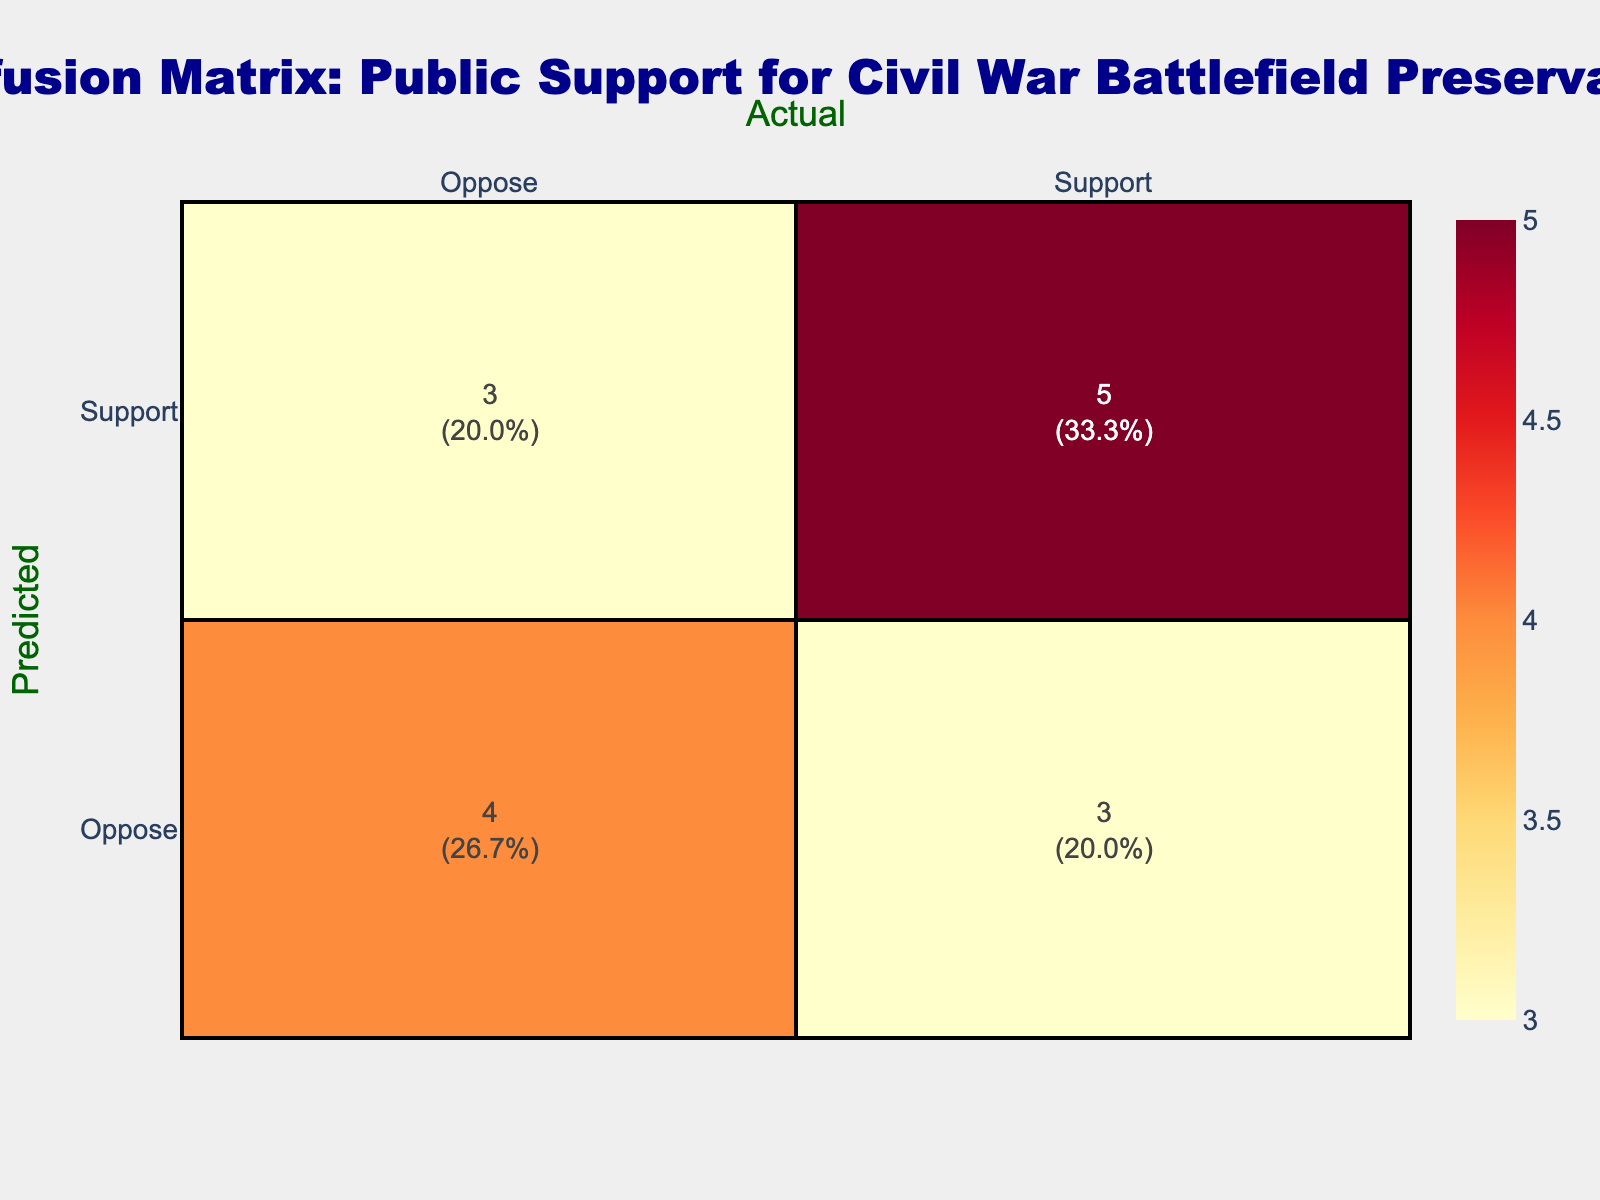What is the count of predicted support when the actual support is also support? In the table, we look for the intersection where both predicted and actual values are "Support." This occurs in three instances.
Answer: 3 What is the total count of instances where the prediction was "Oppose"? We sum the total counts in the "Oppose" row, which includes two instances of actual "Oppose" (count 2) and two instances of actual "Support" (count 2), giving a total of four.
Answer: 4 Is it true that the predicted "Oppose" was more frequent than predicted "Support"? By comparing the tallies, predicted "Support" has 8 occurrences while predicted "Oppose" has 4 occurrences. Therefore, it is false that predicted "Oppose" is more frequent.
Answer: No What is the percentage of actual support instances that were correctly predicted as support? We calculate the number of correctly predicted "Support" instances, which is 3, divided by the total actual "Support" instances, also 5 (3 correct + 2 incorrect), leading to a percentage of (3/5)*100 = 60%.
Answer: 60% What is the difference in counts between predicted support and predicted oppose? We count the occurrences of "Support" (8) and "Oppose" (4) in the predicted values, and the difference is calculated as 8 - 4 = 4.
Answer: 4 How many times was the prediction correct when the actual response was "Oppose"? To find the correct predictions when actual is "Oppose," we look at the "Oppose" row and note that there are 3 instances (two when both are "Oppose" and one incorrect prediction when actual was "Support").
Answer: 3 What is the total number of classifications in the confusion matrix? We sum all instances in the confusion matrix: 8 (predicted "Support") + 4 (predicted "Oppose") = 12 total instances.
Answer: 12 What is the average prediction count for actual support based on the given data? We total the predictions for actual "Support": 3 (correct) + 2 (incorrect) = 5, then divide them by the number of actual support counts which is 5, leading to an average of 5/5 = 1.
Answer: 1 What was the most common prediction type based on the data? To determine this, we compare the counts of "Support" (8) and "Oppose" (4) predictions. Since "Support" has the highest count, it is the most common prediction type.
Answer: Support 